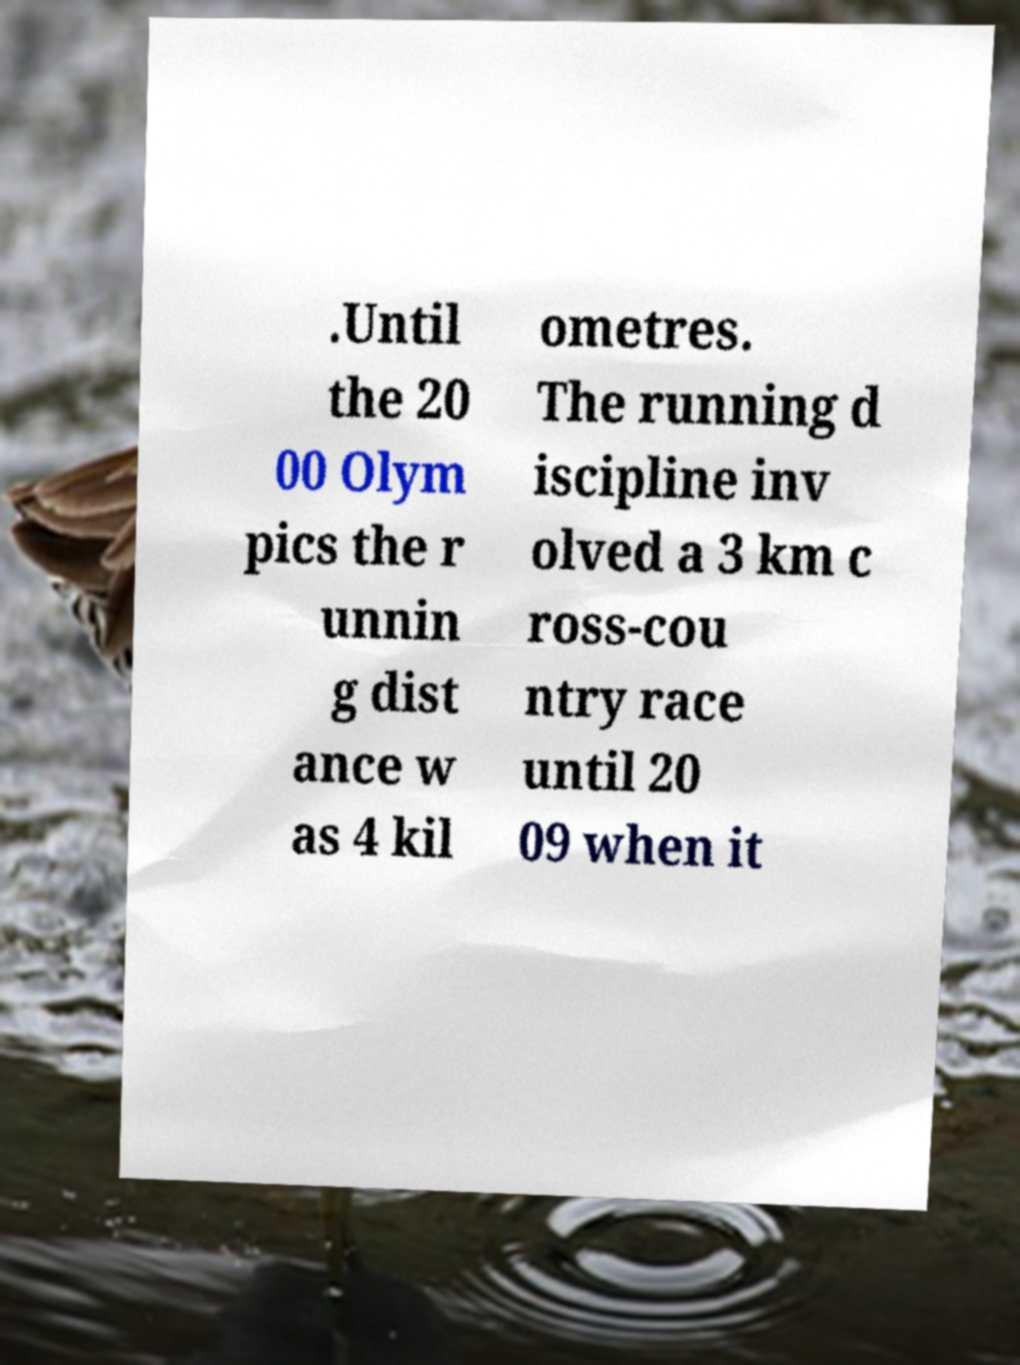For documentation purposes, I need the text within this image transcribed. Could you provide that? .Until the 20 00 Olym pics the r unnin g dist ance w as 4 kil ometres. The running d iscipline inv olved a 3 km c ross-cou ntry race until 20 09 when it 